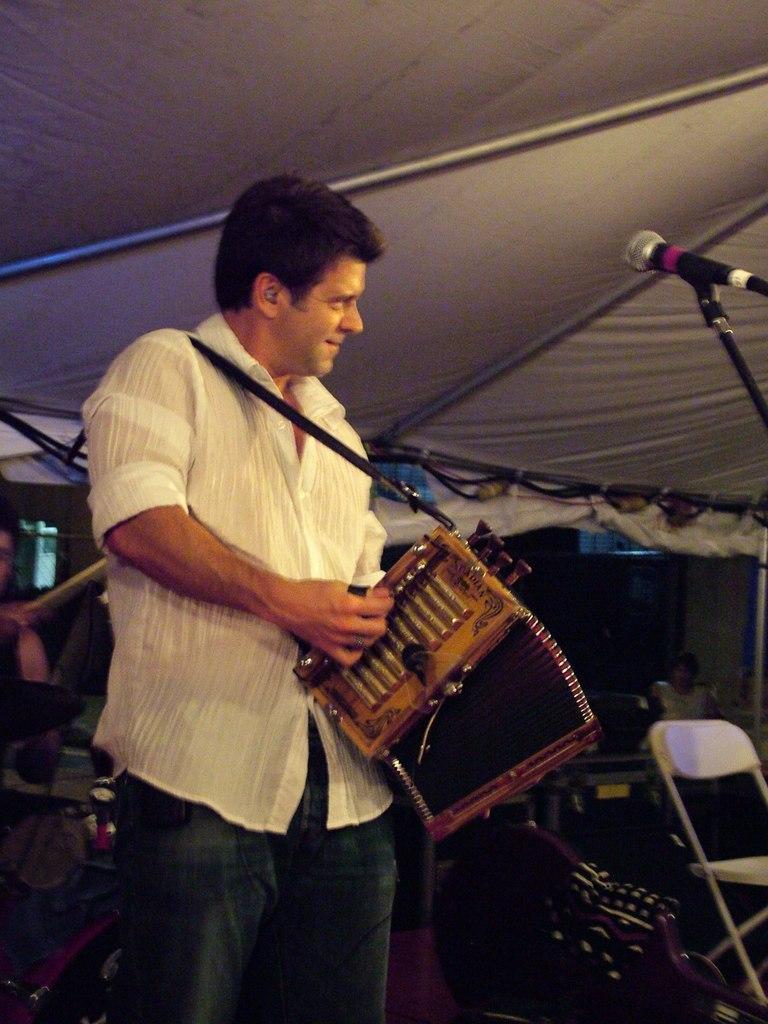How would you summarize this image in a sentence or two? In this image we can see a person standing under a tent holding a musical instrument. On the right side we can see a mic with a stand and a chair. 